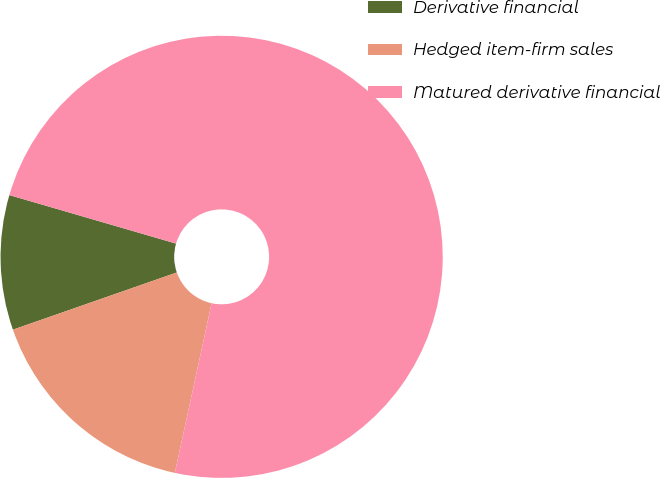Convert chart. <chart><loc_0><loc_0><loc_500><loc_500><pie_chart><fcel>Derivative financial<fcel>Hedged item-firm sales<fcel>Matured derivative financial<nl><fcel>9.85%<fcel>16.26%<fcel>73.89%<nl></chart> 